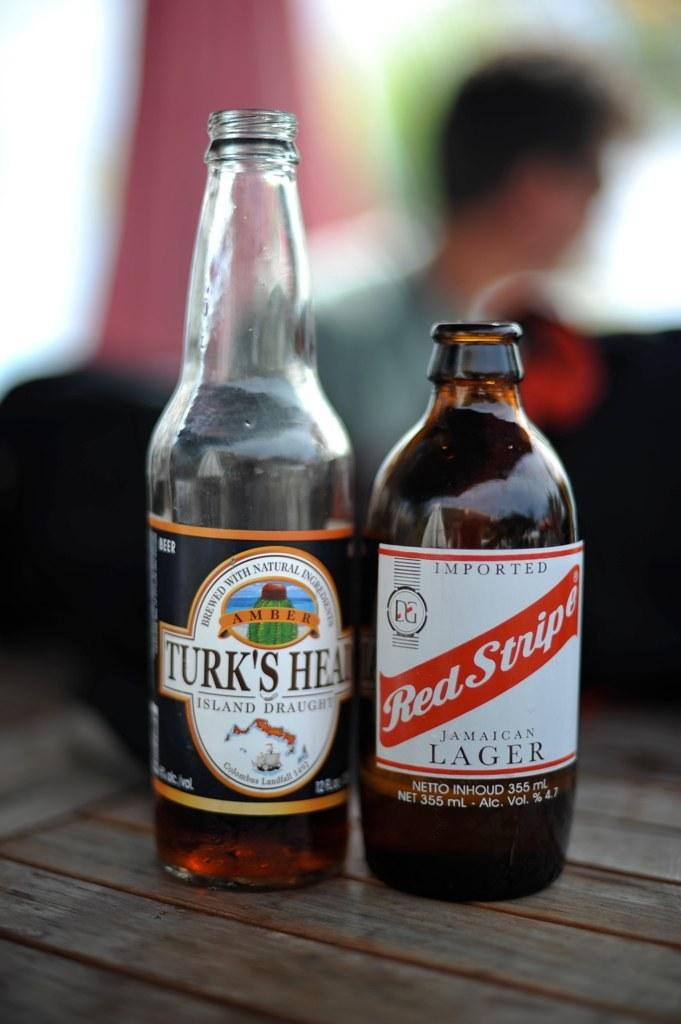How many wine bottles are visible in the image? There are two wine bottles in the image. Where are the wine bottles located? The wine bottles are on a table. What type of machine is used to create the smiles on the wine bottles in the image? There are no smiles on the wine bottles in the image, and no machines are present. 